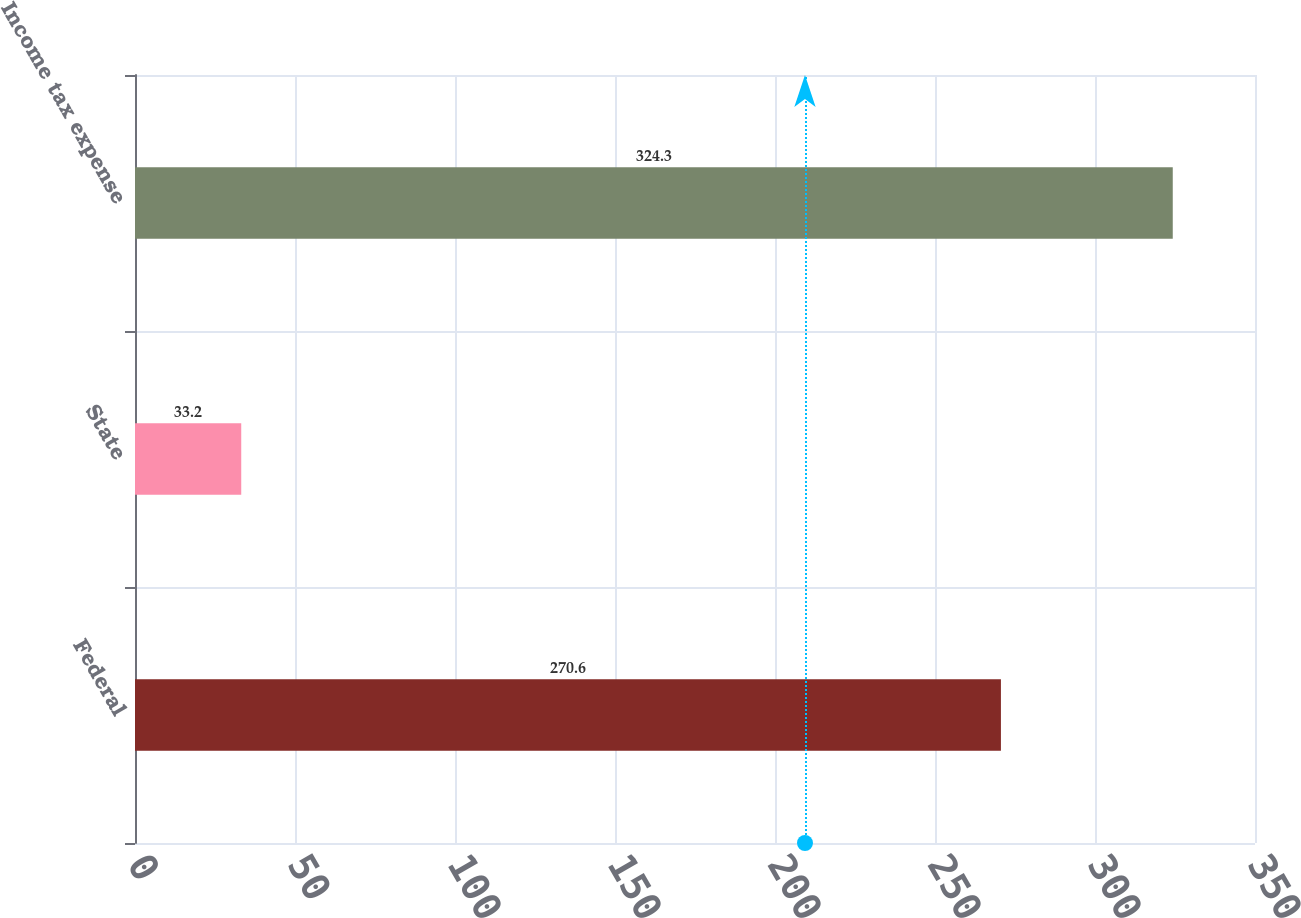<chart> <loc_0><loc_0><loc_500><loc_500><bar_chart><fcel>Federal<fcel>State<fcel>Income tax expense<nl><fcel>270.6<fcel>33.2<fcel>324.3<nl></chart> 